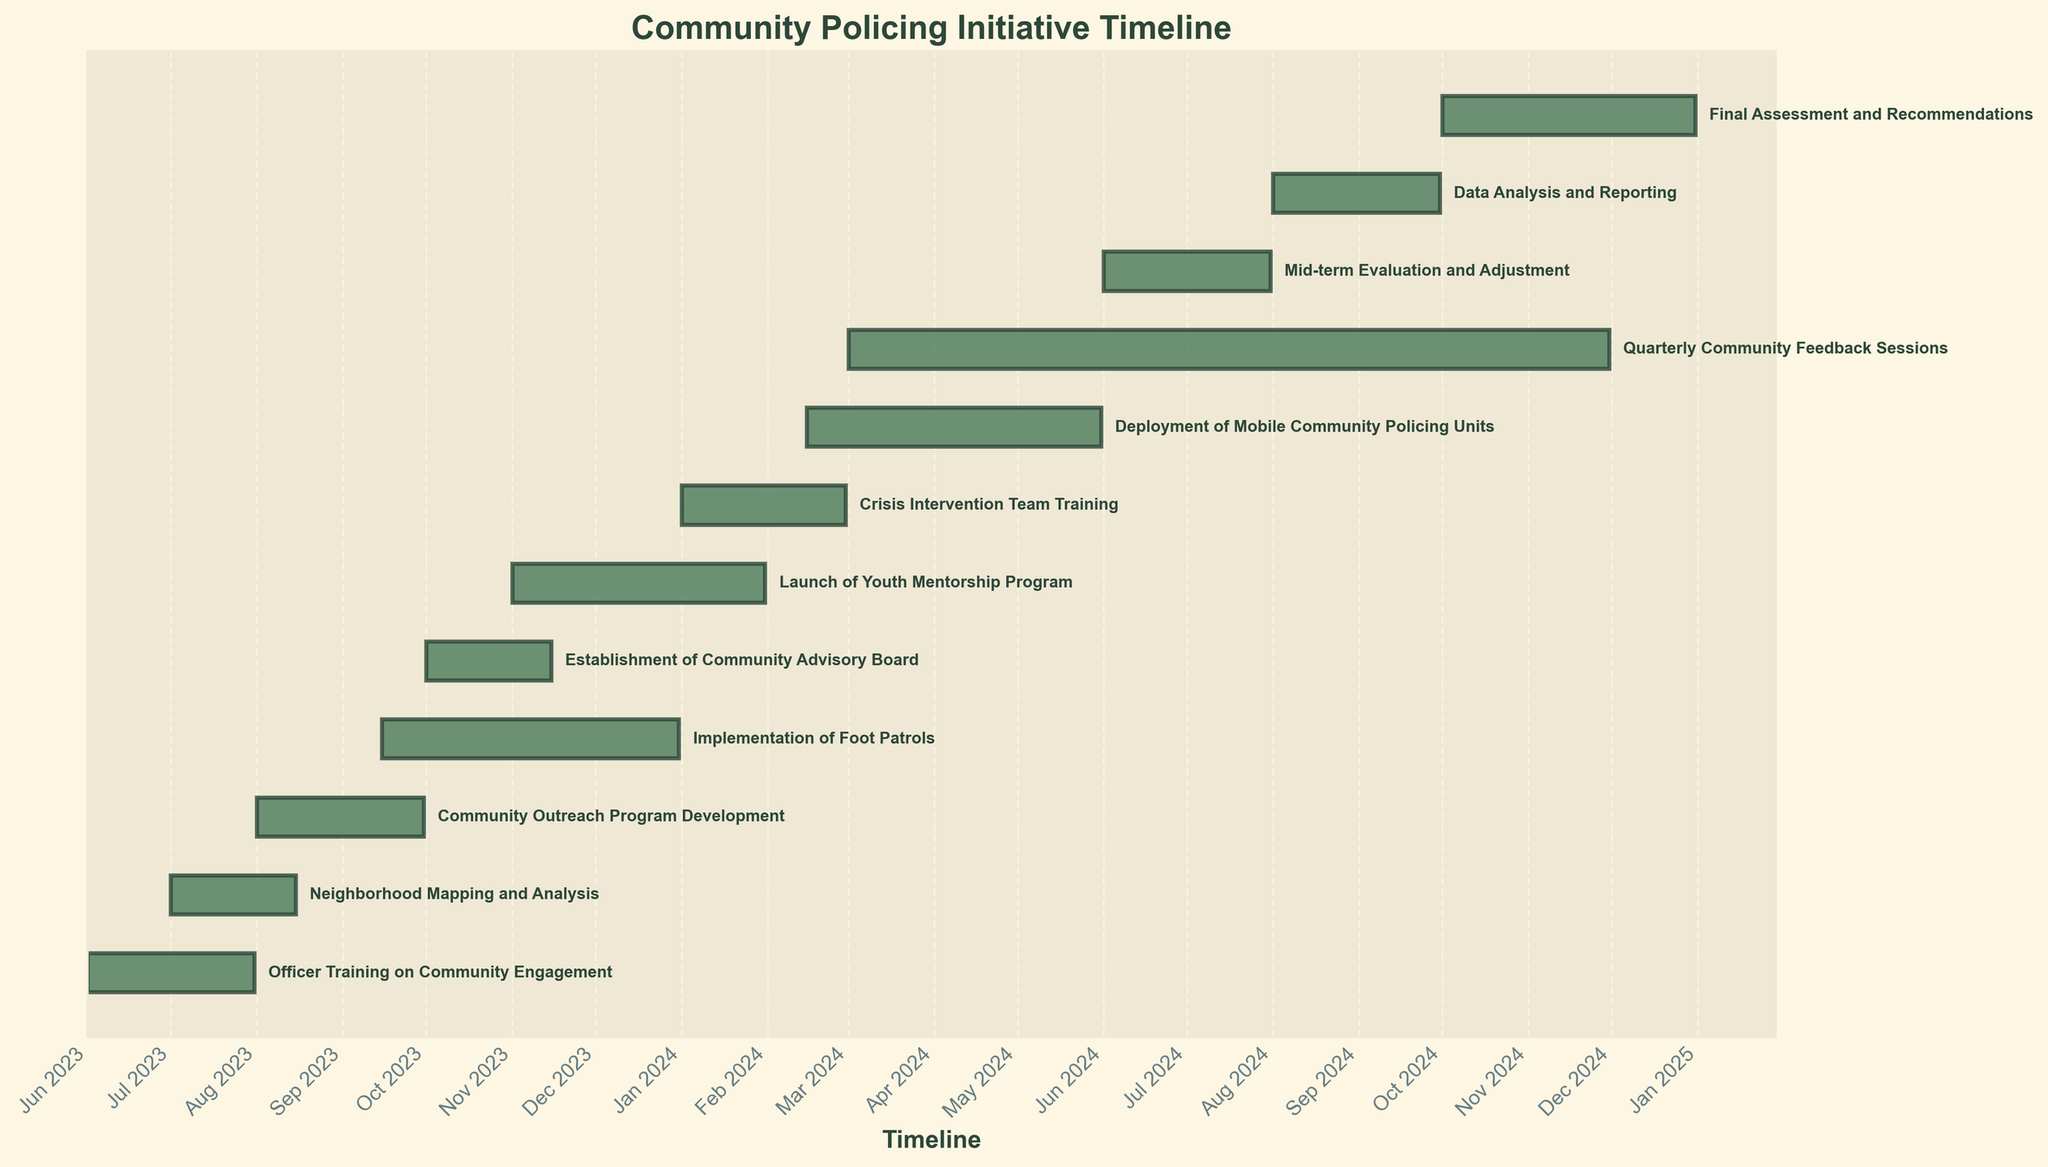What is the title of the chart? The title is displayed at the top of the chart in larger font size, indicating the main topic of the chart.
Answer: Community Policing Initiative Timeline What does the x-axis in the chart represent? The x-axis represents the timeline for the different phases and tasks of the community policing initiative, formatted as months and years.
Answer: Timeline How many tasks are presented in the chart? By counting the number of horizontal bars, each representing a task, you can see the total number of tasks included in the initiative.
Answer: 12 Which task has the shortest duration? By comparing the lengths of the horizontal bars, the shortest one indicates the task with the shortest duration.
Answer: Establishment of Community Advisory Board How much time after the start of "Officer Training on Community Engagement" did the "Community Outreach Program Development" begin? Compare the start dates of the "Officer Training on Community Engagement" and "Community Outreach Program Development" tasks and calculate the difference in days.
Answer: 61 days Which task spans the longest duration, and by how much? Identify the task with the longest horizontal bar and calculate its duration by finding the difference between its start and end dates.
Answer: Quarterly Community Feedback Sessions, 274 days Which two tasks overlap in their start and end dates? Find tasks with overlapping horizontal bars, meaning their start and end dates coincide partially or fully.
Answer: Community Outreach Program Development and Implementation of Foot Patrols When does the "Data Analysis and Reporting" phase begin and end? Look at the start and end points of the horizontal bar corresponding to "Data Analysis and Reporting" on the x-axis.
Answer: August 1, 2024 - September 30, 2024 How does the duration of the "Mid-term Evaluation and Adjustment" compare to the "Final Assessment and Recommendations"? Calculate the duration of both tasks by finding the difference between their start and end dates and compare them.
Answer: Mid-term Evaluation and Adjustment is shorter by 31 days What is the final phase of the community policing initiative, and when does it conclude? Identify the task at the end of the list and check its end date.
Answer: Final Assessment and Recommendations; December 31, 2024 